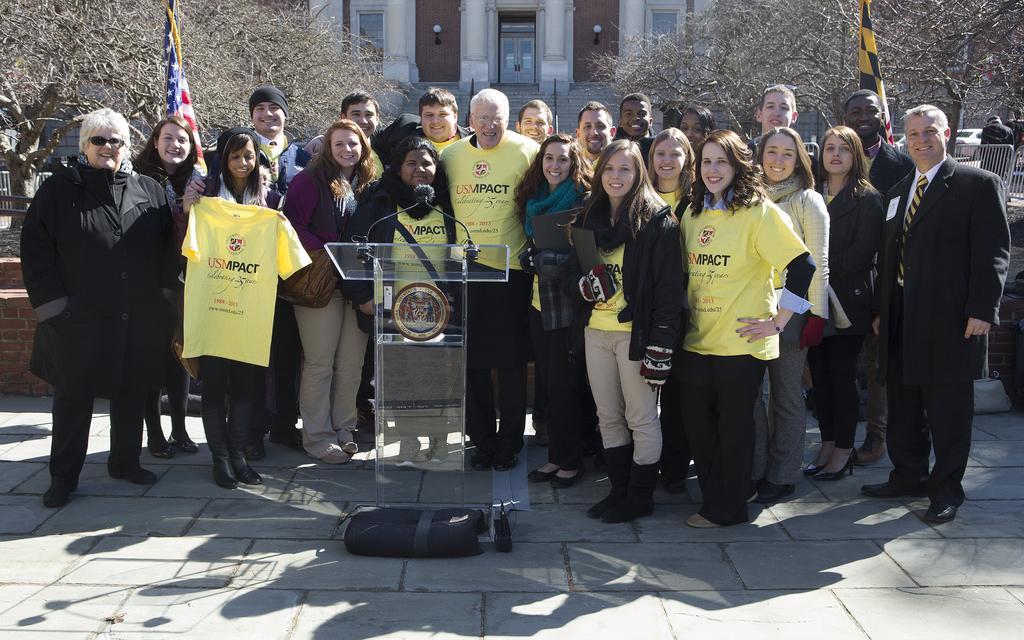Can you describe this image briefly? In this image, we can see a group of people are standing side by side and watching. Here a woman is holding a t-shirt. At the bottom, we can see a glass podium with microphone on the path. Background there are few trees, flags, building, stairs, door, vehicles, barricades and lights. 